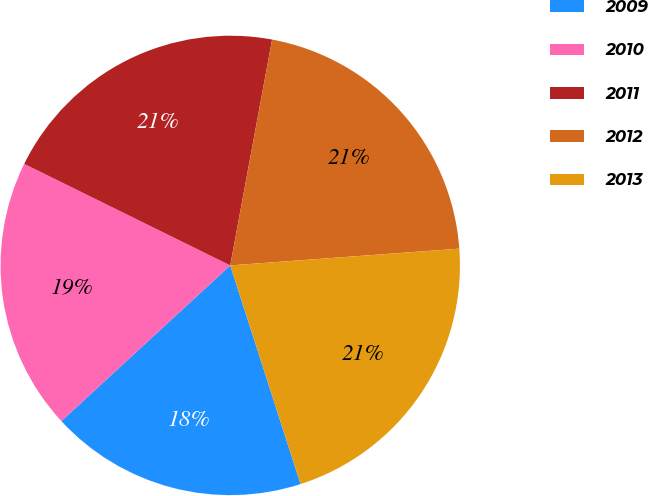Convert chart to OTSL. <chart><loc_0><loc_0><loc_500><loc_500><pie_chart><fcel>2009<fcel>2010<fcel>2011<fcel>2012<fcel>2013<nl><fcel>18.1%<fcel>19.14%<fcel>20.63%<fcel>20.92%<fcel>21.21%<nl></chart> 